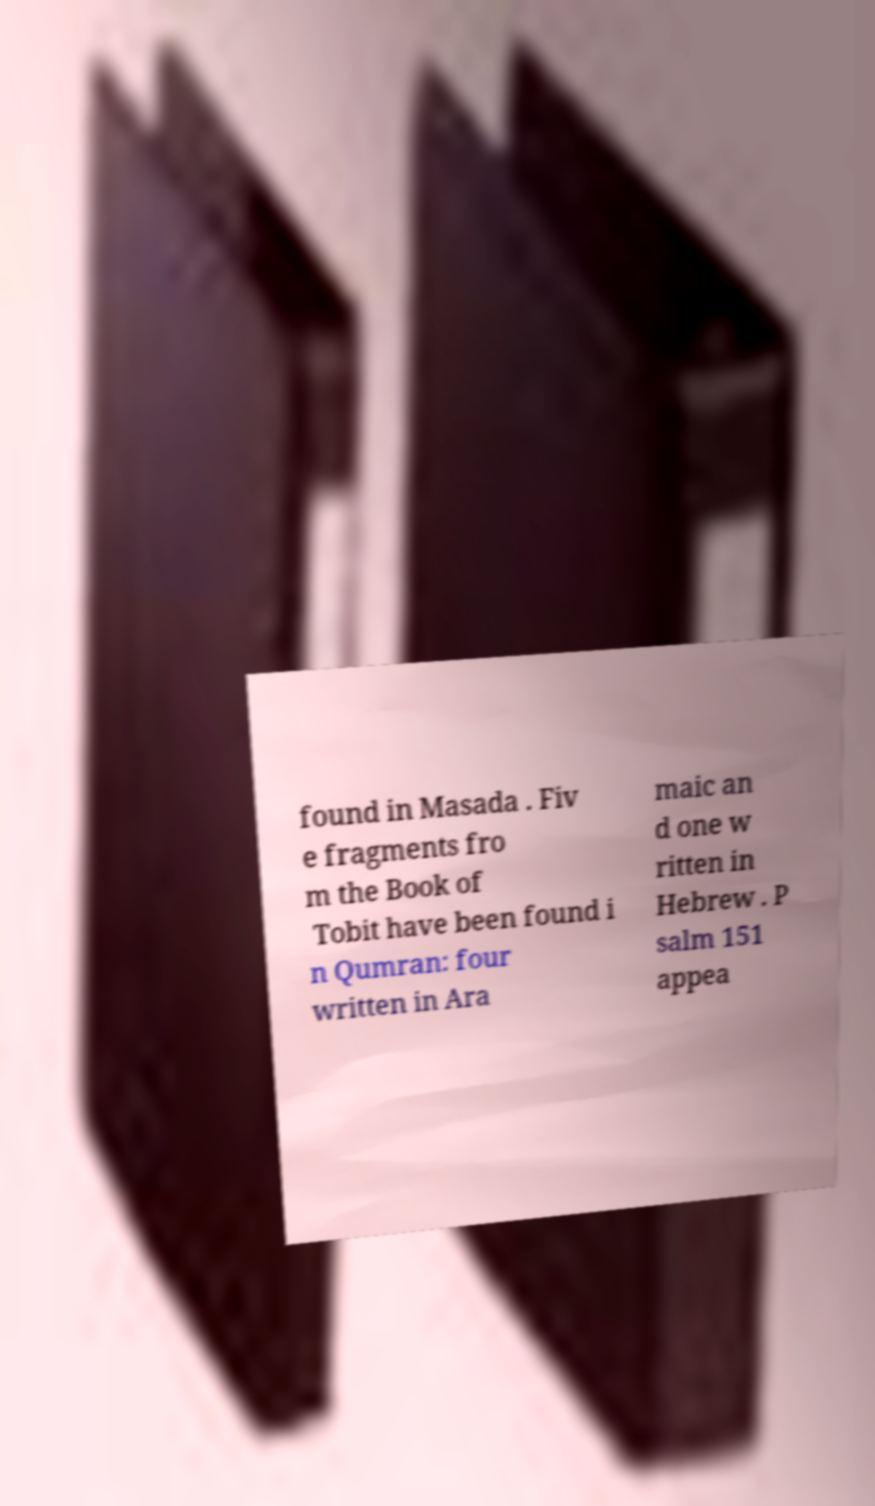Could you extract and type out the text from this image? found in Masada . Fiv e fragments fro m the Book of Tobit have been found i n Qumran: four written in Ara maic an d one w ritten in Hebrew . P salm 151 appea 